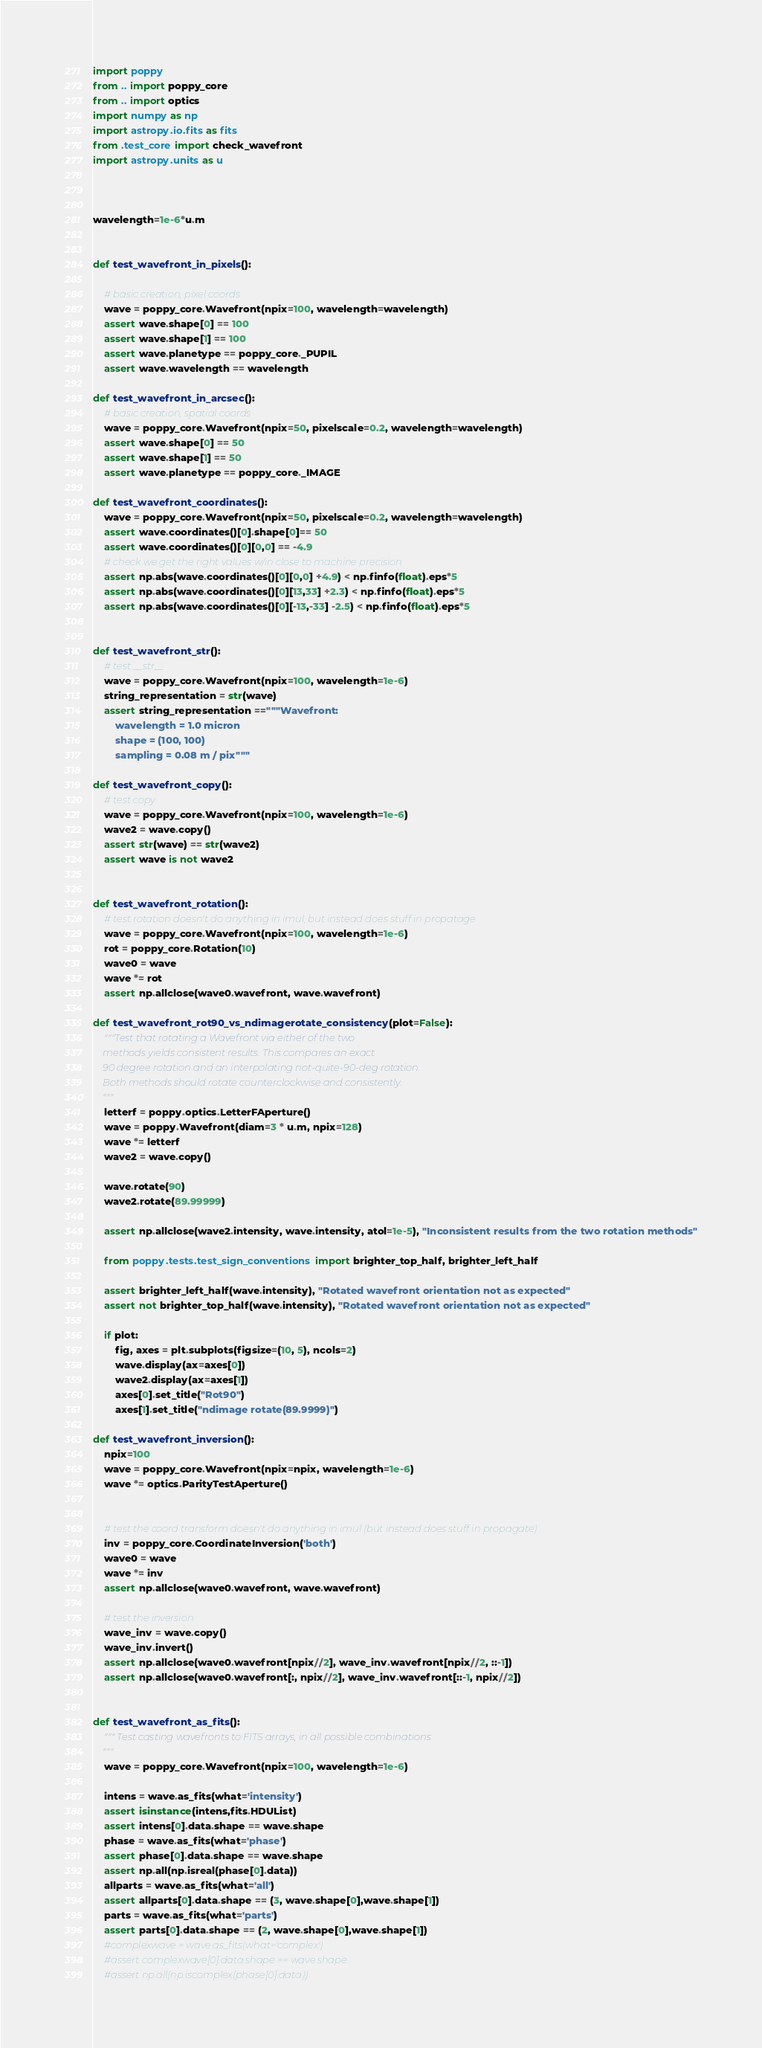Convert code to text. <code><loc_0><loc_0><loc_500><loc_500><_Python_>
import poppy
from .. import poppy_core
from .. import optics
import numpy as np
import astropy.io.fits as fits
from .test_core import check_wavefront
import astropy.units as u



wavelength=1e-6*u.m


def test_wavefront_in_pixels():

    # basic creation, pixel coords
    wave = poppy_core.Wavefront(npix=100, wavelength=wavelength)
    assert wave.shape[0] == 100
    assert wave.shape[1] == 100
    assert wave.planetype == poppy_core._PUPIL
    assert wave.wavelength == wavelength

def test_wavefront_in_arcsec():
    # basic creation, spatial coords
    wave = poppy_core.Wavefront(npix=50, pixelscale=0.2, wavelength=wavelength)
    assert wave.shape[0] == 50
    assert wave.shape[1] == 50
    assert wave.planetype == poppy_core._IMAGE

def test_wavefront_coordinates():
    wave = poppy_core.Wavefront(npix=50, pixelscale=0.2, wavelength=wavelength)
    assert wave.coordinates()[0].shape[0]== 50
    assert wave.coordinates()[0][0,0] == -4.9
    # check we get the right values w/in close to machine precision
    assert np.abs(wave.coordinates()[0][0,0] +4.9) < np.finfo(float).eps*5
    assert np.abs(wave.coordinates()[0][13,33] +2.3) < np.finfo(float).eps*5
    assert np.abs(wave.coordinates()[0][-13,-33] -2.5) < np.finfo(float).eps*5


def test_wavefront_str():
    # test __str__
    wave = poppy_core.Wavefront(npix=100, wavelength=1e-6)
    string_representation = str(wave)
    assert string_representation =="""Wavefront:
        wavelength = 1.0 micron
        shape = (100, 100)
        sampling = 0.08 m / pix"""

def test_wavefront_copy():
    # test copy
    wave = poppy_core.Wavefront(npix=100, wavelength=1e-6)
    wave2 = wave.copy()
    assert str(wave) == str(wave2)
    assert wave is not wave2


def test_wavefront_rotation():
    # test rotation doesn't do anything in imul, but instead does stuff in propatage
    wave = poppy_core.Wavefront(npix=100, wavelength=1e-6)
    rot = poppy_core.Rotation(10)
    wave0 = wave
    wave *= rot
    assert np.allclose(wave0.wavefront, wave.wavefront)

def test_wavefront_rot90_vs_ndimagerotate_consistency(plot=False):
    """Test that rotating a Wavefront via either of the two
    methods yields consistent results. This compares an exact
    90 degree rotation and an interpolating not-quite-90-deg rotation.
    Both methods should rotate counterclockwise and consistently.
    """
    letterf = poppy.optics.LetterFAperture()
    wave = poppy.Wavefront(diam=3 * u.m, npix=128)
    wave *= letterf
    wave2 = wave.copy()

    wave.rotate(90)
    wave2.rotate(89.99999)

    assert np.allclose(wave2.intensity, wave.intensity, atol=1e-5), "Inconsistent results from the two rotation methods"

    from poppy.tests.test_sign_conventions import brighter_top_half, brighter_left_half

    assert brighter_left_half(wave.intensity), "Rotated wavefront orientation not as expected"
    assert not brighter_top_half(wave.intensity), "Rotated wavefront orientation not as expected"

    if plot:
        fig, axes = plt.subplots(figsize=(10, 5), ncols=2)
        wave.display(ax=axes[0])
        wave2.display(ax=axes[1])
        axes[0].set_title("Rot90")
        axes[1].set_title("ndimage rotate(89.9999)")

def test_wavefront_inversion():
    npix=100
    wave = poppy_core.Wavefront(npix=npix, wavelength=1e-6)
    wave *= optics.ParityTestAperture()


    # test the coord transform doesn't do anything in imul (but instead does stuff in propagate)
    inv = poppy_core.CoordinateInversion('both')
    wave0 = wave
    wave *= inv
    assert np.allclose(wave0.wavefront, wave.wavefront)

    # test the inversion
    wave_inv = wave.copy()
    wave_inv.invert()
    assert np.allclose(wave0.wavefront[npix//2], wave_inv.wavefront[npix//2, ::-1])
    assert np.allclose(wave0.wavefront[:, npix//2], wave_inv.wavefront[::-1, npix//2])


def test_wavefront_as_fits():
    """ Test casting wavefronts to FITS arrays, in all possible combinations
    """
    wave = poppy_core.Wavefront(npix=100, wavelength=1e-6)

    intens = wave.as_fits(what='intensity')
    assert isinstance(intens,fits.HDUList)
    assert intens[0].data.shape == wave.shape
    phase = wave.as_fits(what='phase')
    assert phase[0].data.shape == wave.shape
    assert np.all(np.isreal(phase[0].data))
    allparts = wave.as_fits(what='all')
    assert allparts[0].data.shape == (3, wave.shape[0],wave.shape[1])
    parts = wave.as_fits(what='parts')
    assert parts[0].data.shape == (2, wave.shape[0],wave.shape[1])
    #complexwave = wave.as_fits(what='complex')
    #assert complexwave[0].data.shape == wave.shape
    #assert np.all(np.iscomplex(phase[0].data))

</code> 